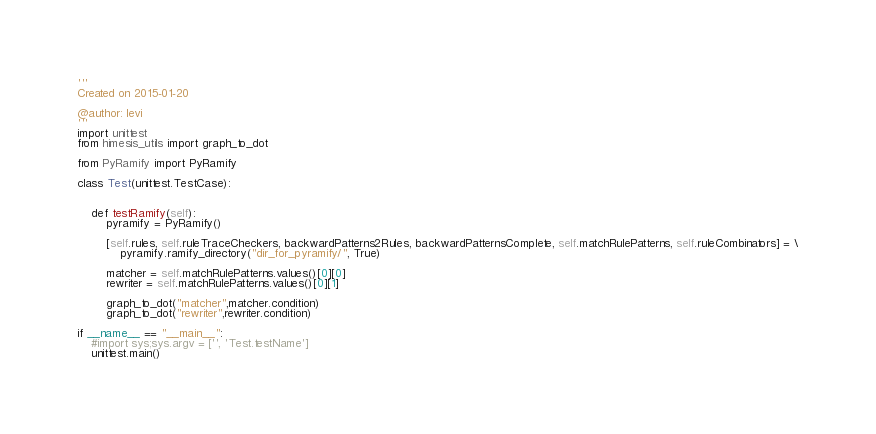<code> <loc_0><loc_0><loc_500><loc_500><_Python_>'''
Created on 2015-01-20

@author: levi
'''
import unittest
from himesis_utils import graph_to_dot

from PyRamify import PyRamify

class Test(unittest.TestCase):


    def testRamify(self):
        pyramify = PyRamify()

        [self.rules, self.ruleTraceCheckers, backwardPatterns2Rules, backwardPatternsComplete, self.matchRulePatterns, self.ruleCombinators] = \
            pyramify.ramify_directory("dir_for_pyramify/", True)
            
        matcher = self.matchRulePatterns.values()[0][0]
        rewriter = self.matchRulePatterns.values()[0][1]
        
        graph_to_dot("matcher",matcher.condition)
        graph_to_dot("rewriter",rewriter.condition)

if __name__ == "__main__":
    #import sys;sys.argv = ['', 'Test.testName']
    unittest.main()</code> 